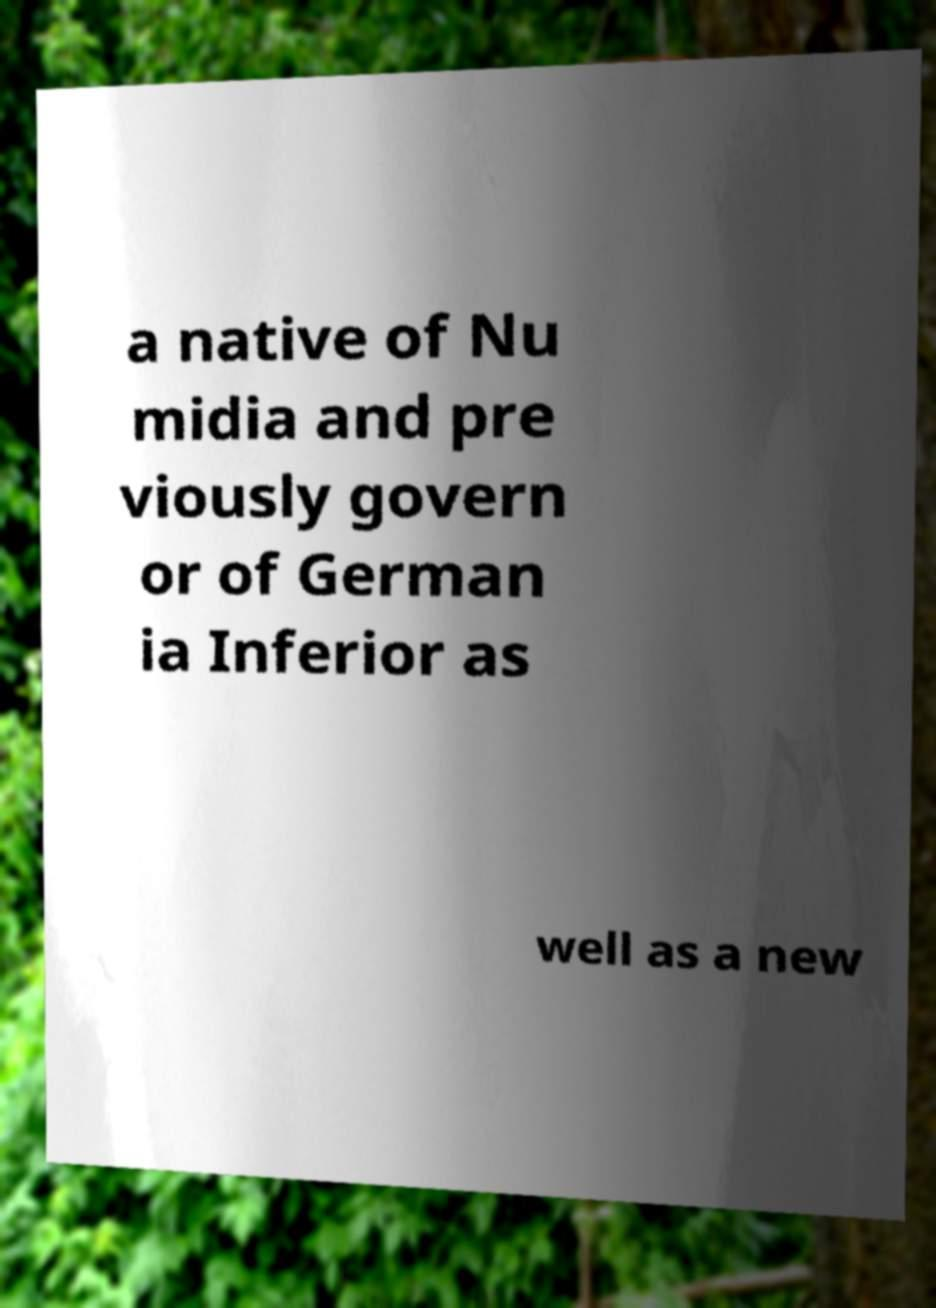There's text embedded in this image that I need extracted. Can you transcribe it verbatim? a native of Nu midia and pre viously govern or of German ia Inferior as well as a new 